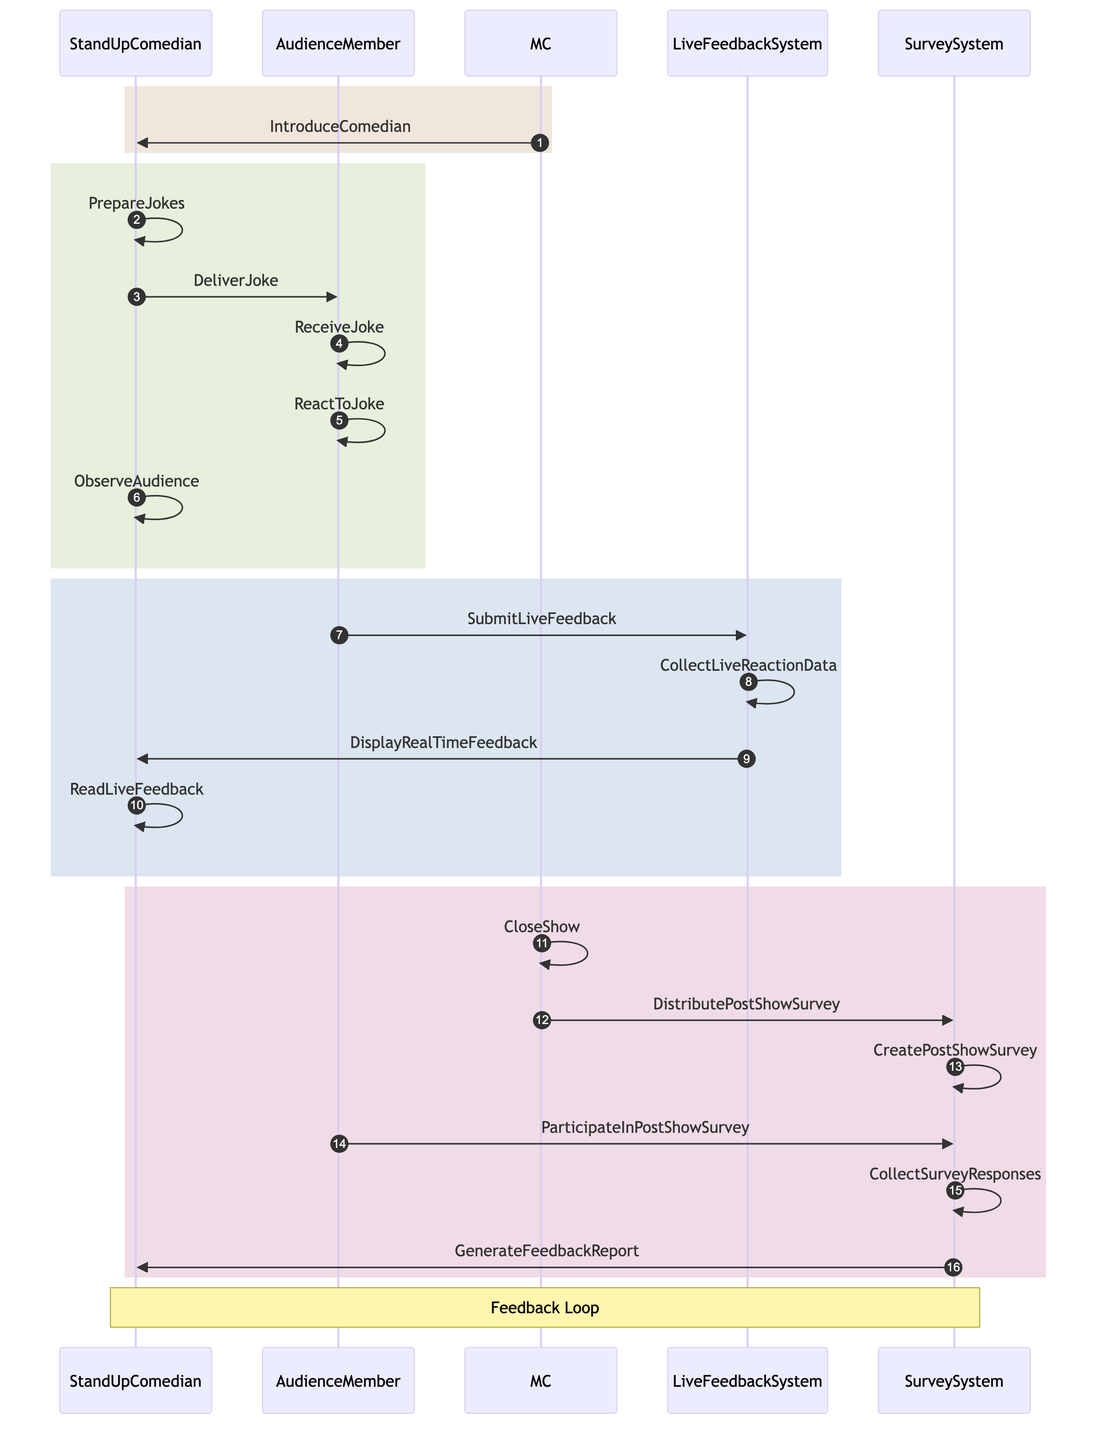What's the first action in the sequence diagram? The first action in the sequence diagram is "IntroduceComedian", which occurs when the MC introduces the Stand-Up Comedian.
Answer: IntroduceComedian How many entities are shown in the diagram? The diagram displays a total of five entities: StandUpComedian, AudienceMember, MC, LiveFeedbackSystem, and SurveySystem.
Answer: Five What does the AudienceMember do after receiving the joke? After receiving the joke, the AudienceMember reacts to the joke, which shows their response to the Stand-Up Comedian's delivery.
Answer: ReactToJoke What action occurs just before the MC closes the show? Just before the closing of the show, the MC distributes the post-show survey to gather feedback from the audience members.
Answer: DistributePostShowSurvey Which system is responsible for collecting live reaction data? The LiveFeedbackSystem is responsible for collecting live reaction data submitted by the audience during the performance.
Answer: LiveFeedbackSystem What is the last action taken by the SurveySystem? The last action taken by the SurveySystem is generating the feedback report, which summarizes the responses gathered from the post-show survey.
Answer: GenerateFeedbackReport How do audience members provide live feedback? Audience members provide live feedback by submitting their reactions through the LiveFeedbackSystem during the performance.
Answer: SubmitLiveFeedback Why is observing the audience an important action for the Stand-Up Comedian? Observing the audience allows the Stand-Up Comedian to gauge audience reactions and adjust performance accordingly, ensuring better engagement and effectiveness of jokes.
Answer: To gauge reactions What note is included over the Stand-Up Comedian and SurveySystem in the diagram? The note included over the Stand-Up Comedian and SurveySystem is "Feedback Loop", indicating that there's an ongoing process of collecting and utilizing feedback for improvement.
Answer: Feedback Loop 